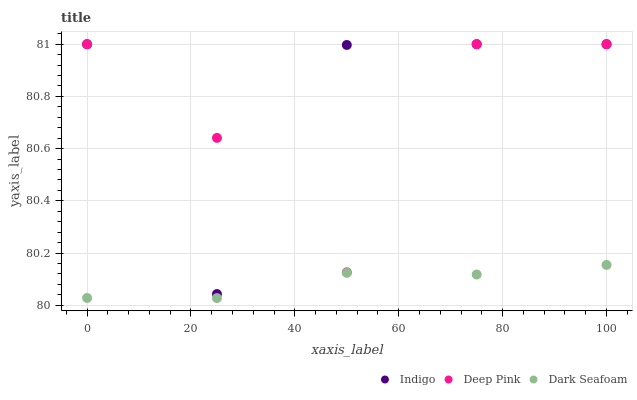Does Dark Seafoam have the minimum area under the curve?
Answer yes or no. Yes. Does Indigo have the maximum area under the curve?
Answer yes or no. Yes. Does Deep Pink have the minimum area under the curve?
Answer yes or no. No. Does Deep Pink have the maximum area under the curve?
Answer yes or no. No. Is Dark Seafoam the smoothest?
Answer yes or no. Yes. Is Indigo the roughest?
Answer yes or no. Yes. Is Deep Pink the smoothest?
Answer yes or no. No. Is Deep Pink the roughest?
Answer yes or no. No. Does Dark Seafoam have the lowest value?
Answer yes or no. Yes. Does Indigo have the lowest value?
Answer yes or no. No. Does Indigo have the highest value?
Answer yes or no. Yes. Is Dark Seafoam less than Indigo?
Answer yes or no. Yes. Is Deep Pink greater than Dark Seafoam?
Answer yes or no. Yes. Does Deep Pink intersect Indigo?
Answer yes or no. Yes. Is Deep Pink less than Indigo?
Answer yes or no. No. Is Deep Pink greater than Indigo?
Answer yes or no. No. Does Dark Seafoam intersect Indigo?
Answer yes or no. No. 